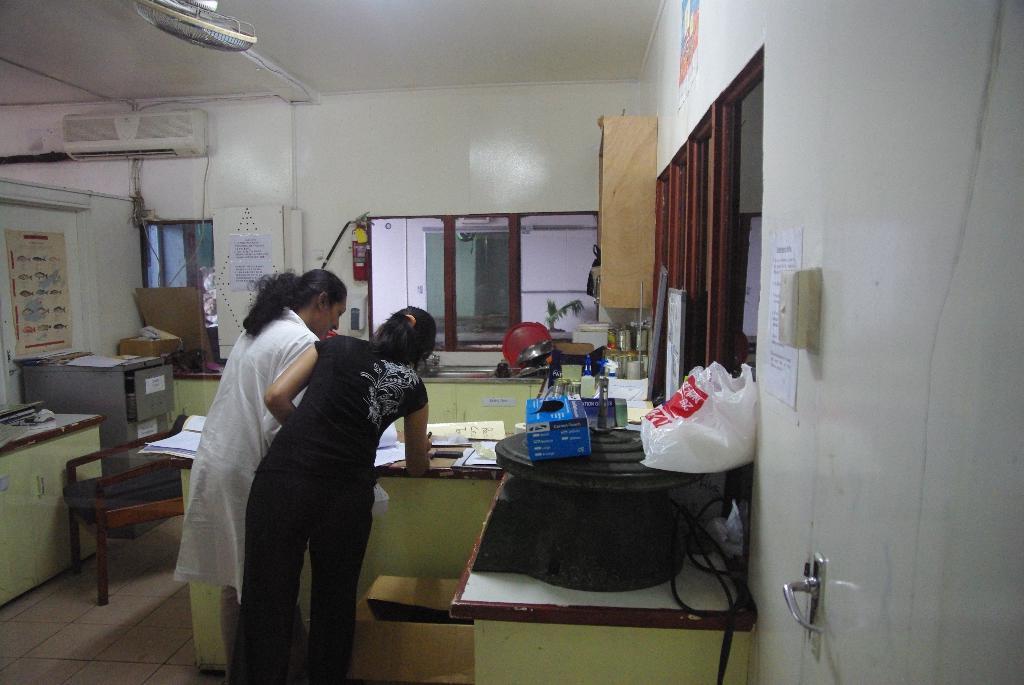In one or two sentences, can you explain what this image depicts? In this picture we can see two woman bending and writing on paper placed on a table where on table we can see boxes, plastic covers, bottles and in background we can see wall, fire extinguisher, window, poster, AC. 